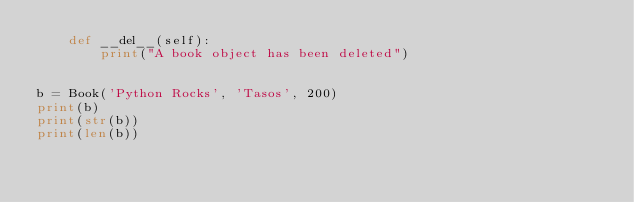<code> <loc_0><loc_0><loc_500><loc_500><_Python_>    def __del__(self):
        print("A book object has been deleted")


b = Book('Python Rocks', 'Tasos', 200)
print(b)
print(str(b))
print(len(b))

</code> 